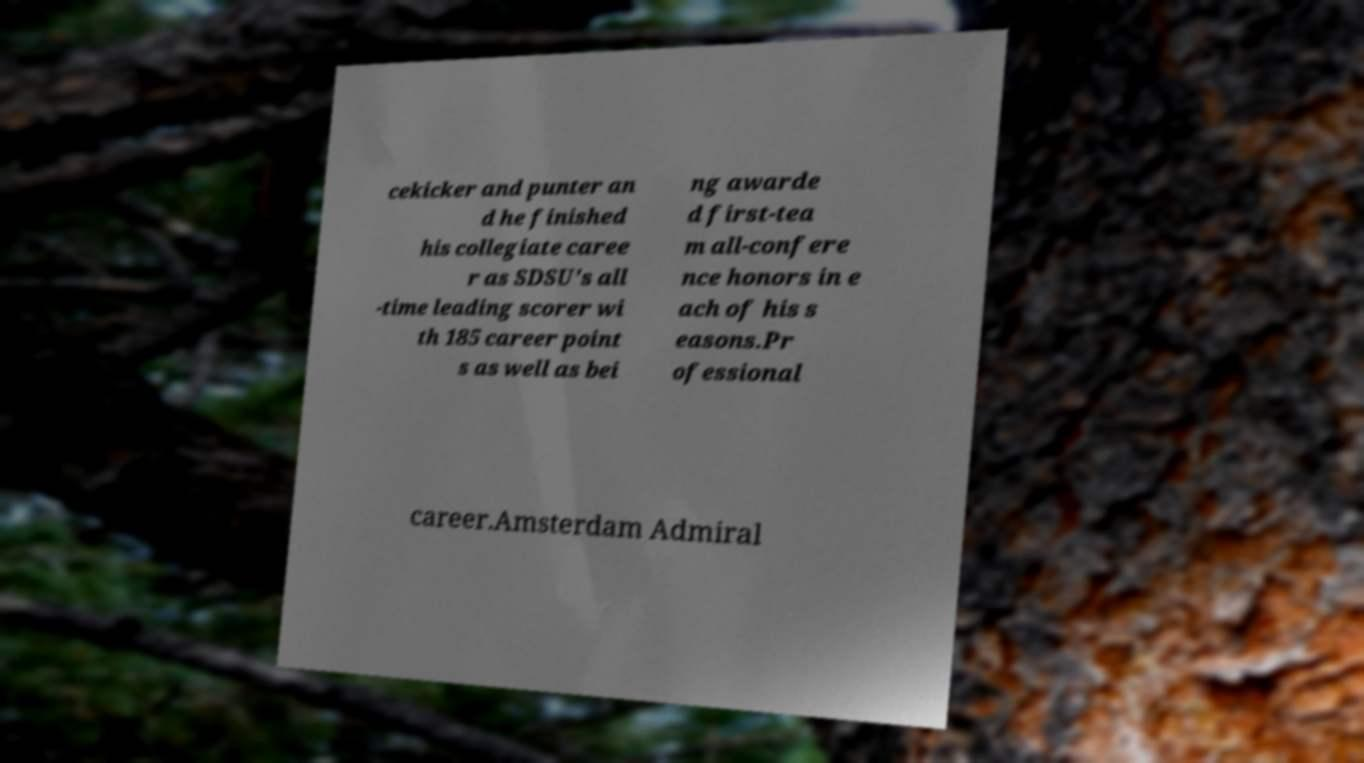Please identify and transcribe the text found in this image. cekicker and punter an d he finished his collegiate caree r as SDSU's all -time leading scorer wi th 185 career point s as well as bei ng awarde d first-tea m all-confere nce honors in e ach of his s easons.Pr ofessional career.Amsterdam Admiral 